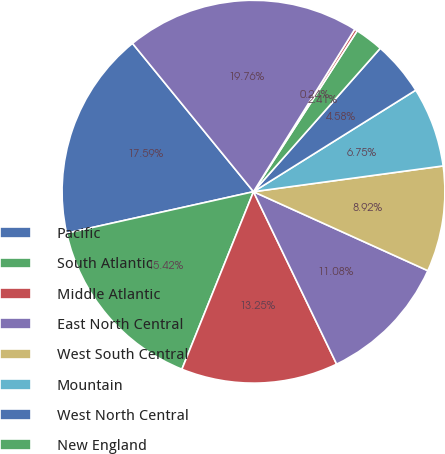Convert chart. <chart><loc_0><loc_0><loc_500><loc_500><pie_chart><fcel>Pacific<fcel>South Atlantic<fcel>Middle Atlantic<fcel>East North Central<fcel>West South Central<fcel>Mountain<fcel>West North Central<fcel>New England<fcel>East South Central<fcel>Subtotal-US<nl><fcel>17.59%<fcel>15.42%<fcel>13.25%<fcel>11.08%<fcel>8.92%<fcel>6.75%<fcel>4.58%<fcel>2.41%<fcel>0.24%<fcel>19.76%<nl></chart> 